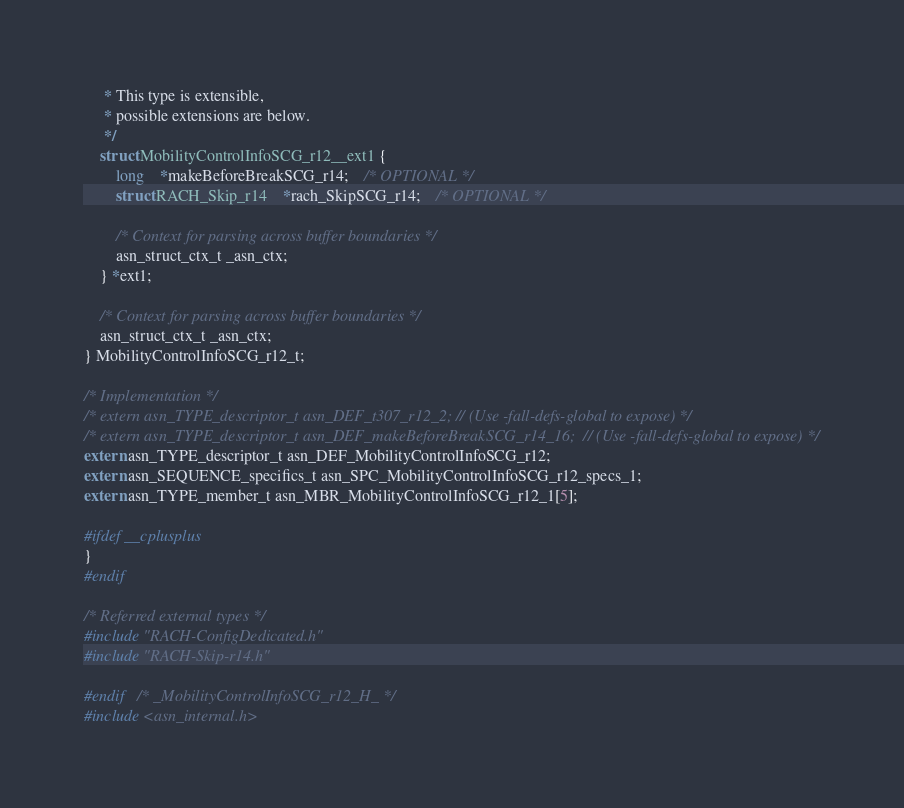Convert code to text. <code><loc_0><loc_0><loc_500><loc_500><_C_>	 * This type is extensible,
	 * possible extensions are below.
	 */
	struct MobilityControlInfoSCG_r12__ext1 {
		long	*makeBeforeBreakSCG_r14;	/* OPTIONAL */
		struct RACH_Skip_r14	*rach_SkipSCG_r14;	/* OPTIONAL */
		
		/* Context for parsing across buffer boundaries */
		asn_struct_ctx_t _asn_ctx;
	} *ext1;
	
	/* Context for parsing across buffer boundaries */
	asn_struct_ctx_t _asn_ctx;
} MobilityControlInfoSCG_r12_t;

/* Implementation */
/* extern asn_TYPE_descriptor_t asn_DEF_t307_r12_2;	// (Use -fall-defs-global to expose) */
/* extern asn_TYPE_descriptor_t asn_DEF_makeBeforeBreakSCG_r14_16;	// (Use -fall-defs-global to expose) */
extern asn_TYPE_descriptor_t asn_DEF_MobilityControlInfoSCG_r12;
extern asn_SEQUENCE_specifics_t asn_SPC_MobilityControlInfoSCG_r12_specs_1;
extern asn_TYPE_member_t asn_MBR_MobilityControlInfoSCG_r12_1[5];

#ifdef __cplusplus
}
#endif

/* Referred external types */
#include "RACH-ConfigDedicated.h"
#include "RACH-Skip-r14.h"

#endif	/* _MobilityControlInfoSCG_r12_H_ */
#include <asn_internal.h>
</code> 